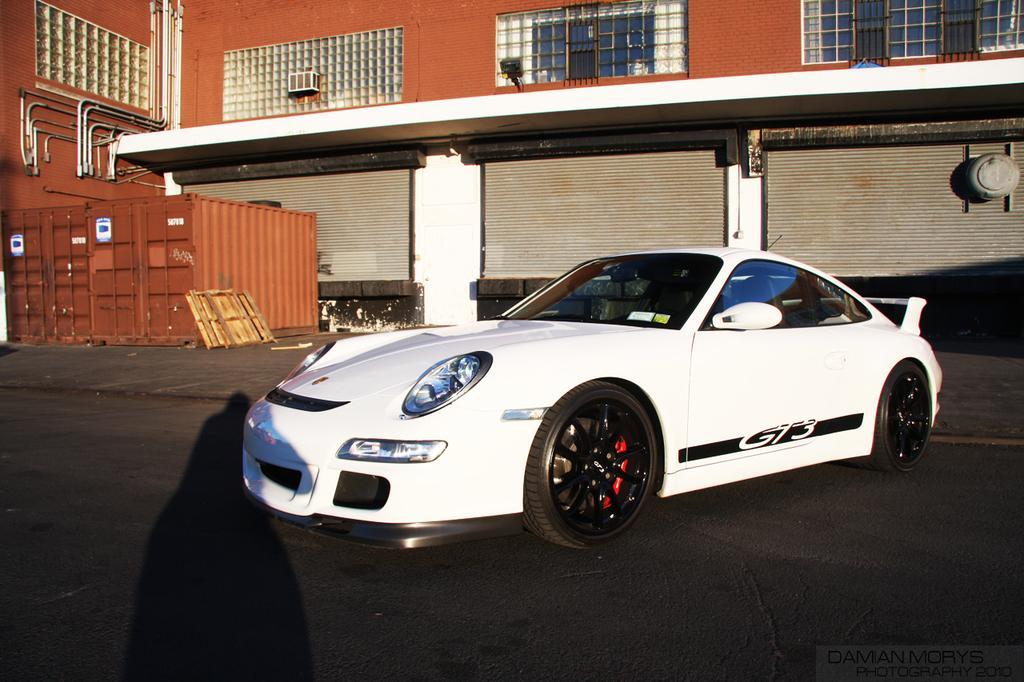Describe this image in one or two sentences. In this image I can see a car which is white and black in color on the ground. In the background I can see a brown colored container, a wooden object, few rolling shutters to the building, a building which is white and brown in color, few pipes and few windows of the building. 